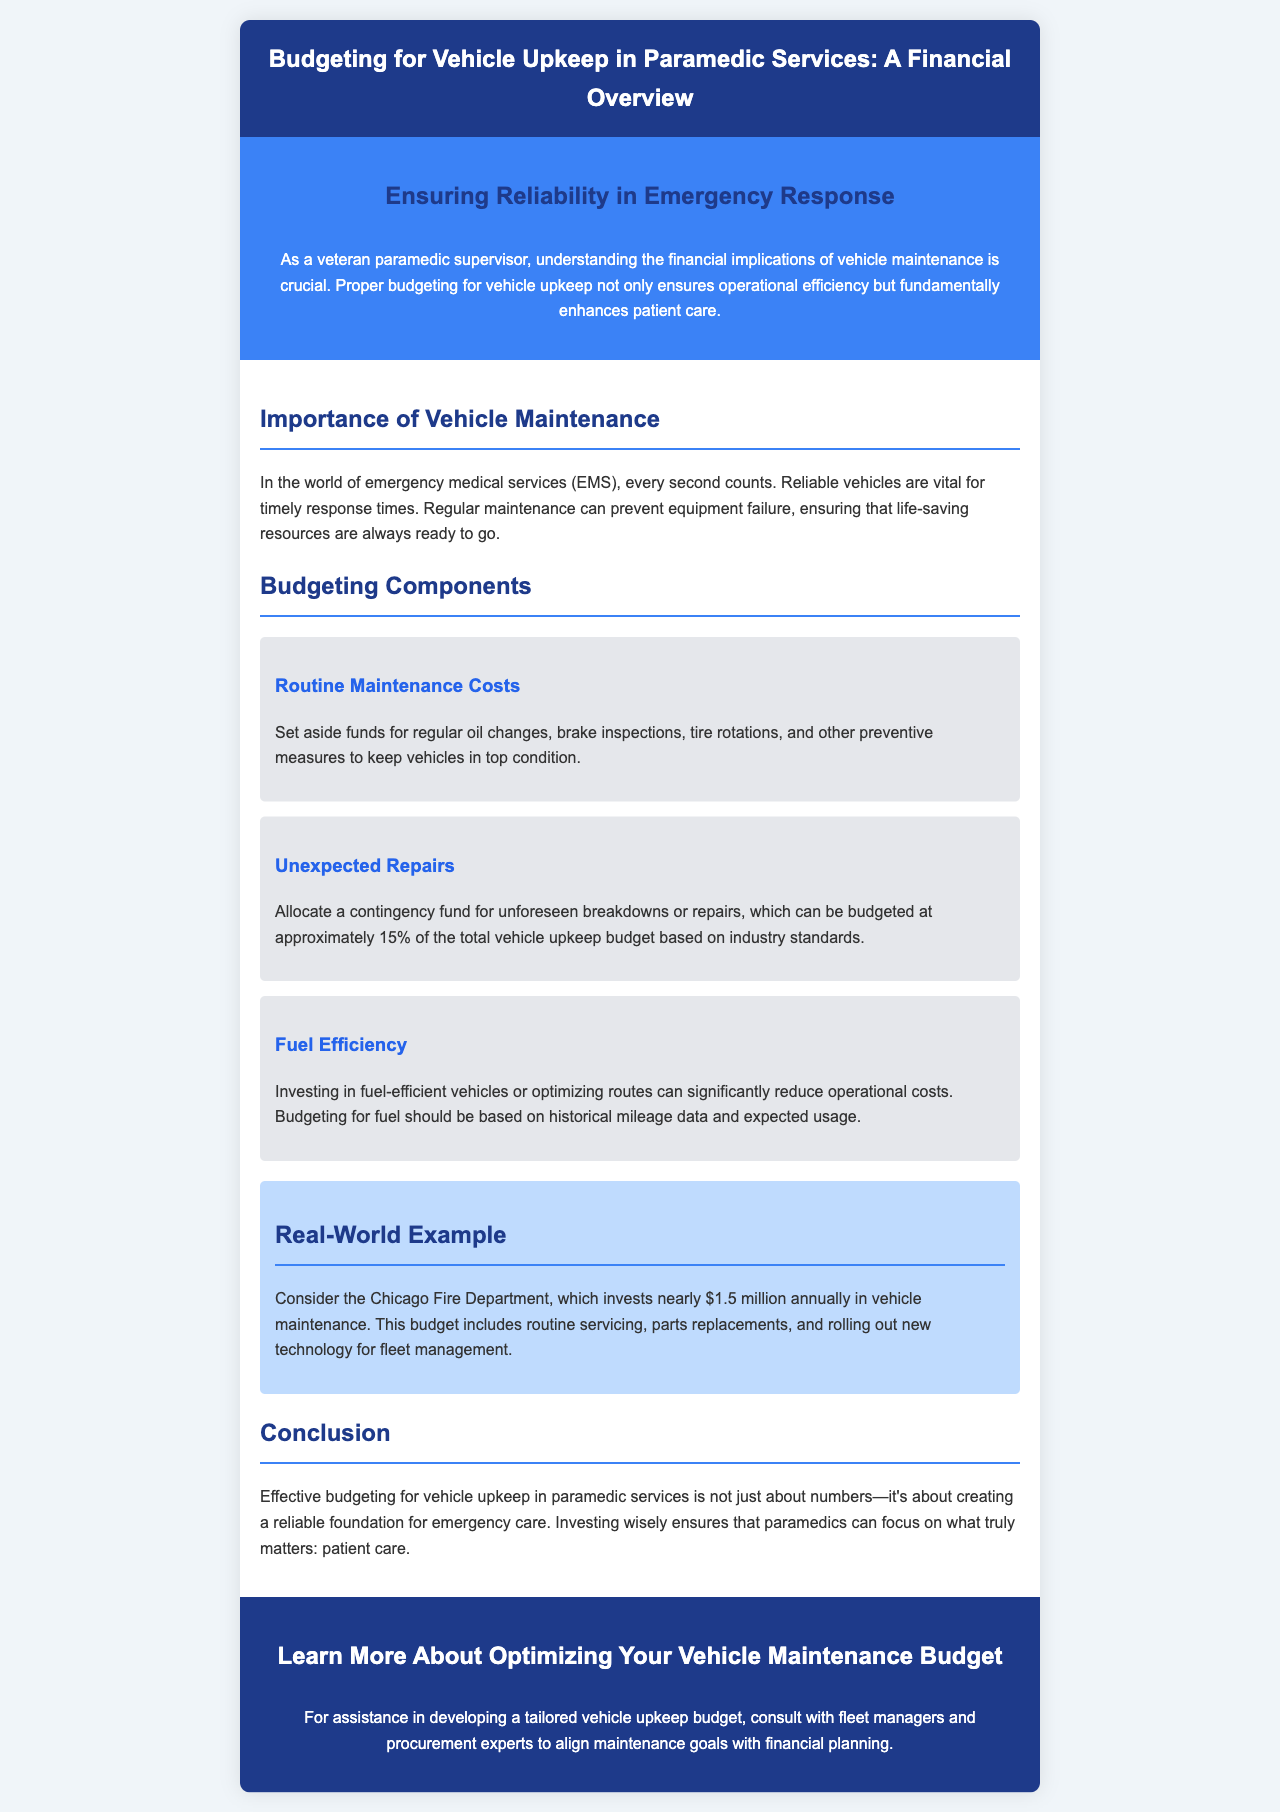what is the title of the brochure? The title is clearly stated in the header of the brochure.
Answer: Budgeting for Vehicle Upkeep in Paramedic Services: A Financial Overview who is the target audience of the brochure? The audience is mentioned in the introduction emphasizing the importance of the content for that group.
Answer: veteran paramedic supervisor what percentage of the total vehicle upkeep budget should be allocated for unexpected repairs? The document specifies this percentage under budgeting components.
Answer: 15% how much does the Chicago Fire Department invest annually in vehicle maintenance? The specific investment amount is provided in the real-world example section of the document.
Answer: $1.5 million what is emphasized as crucial for ensuring reliable emergency response? The introduction highlights a significant aspect for effective emergency services.
Answer: financial implications of vehicle maintenance what are examples of routine maintenance costs mentioned? The content lists specific types of routine maintenance that should be budgeted for.
Answer: oil changes, brake inspections, tire rotations what does effective budgeting for vehicle upkeep create for emergency care? This result is mentioned in the conclusion of the document.
Answer: reliable foundation who should be consulted for assistance in developing a vehicle upkeep budget? The document suggests consulting a particular group for expert advice.
Answer: fleet managers and procurement experts 